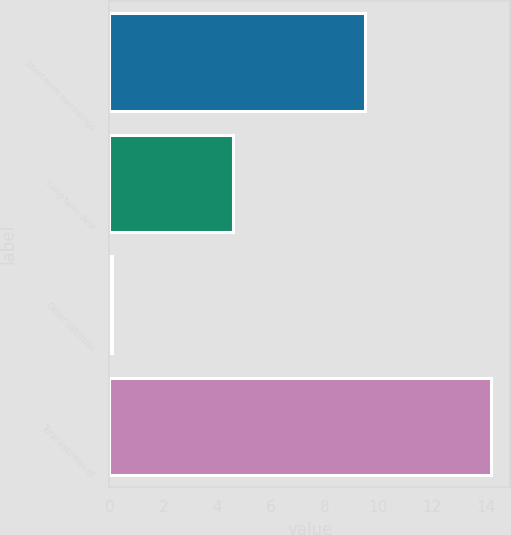Convert chart. <chart><loc_0><loc_0><loc_500><loc_500><bar_chart><fcel>Short-term borrowings<fcel>Long-term debt<fcel>Other liabilities<fcel>Total liabilities of<nl><fcel>9.5<fcel>4.6<fcel>0.1<fcel>14.2<nl></chart> 